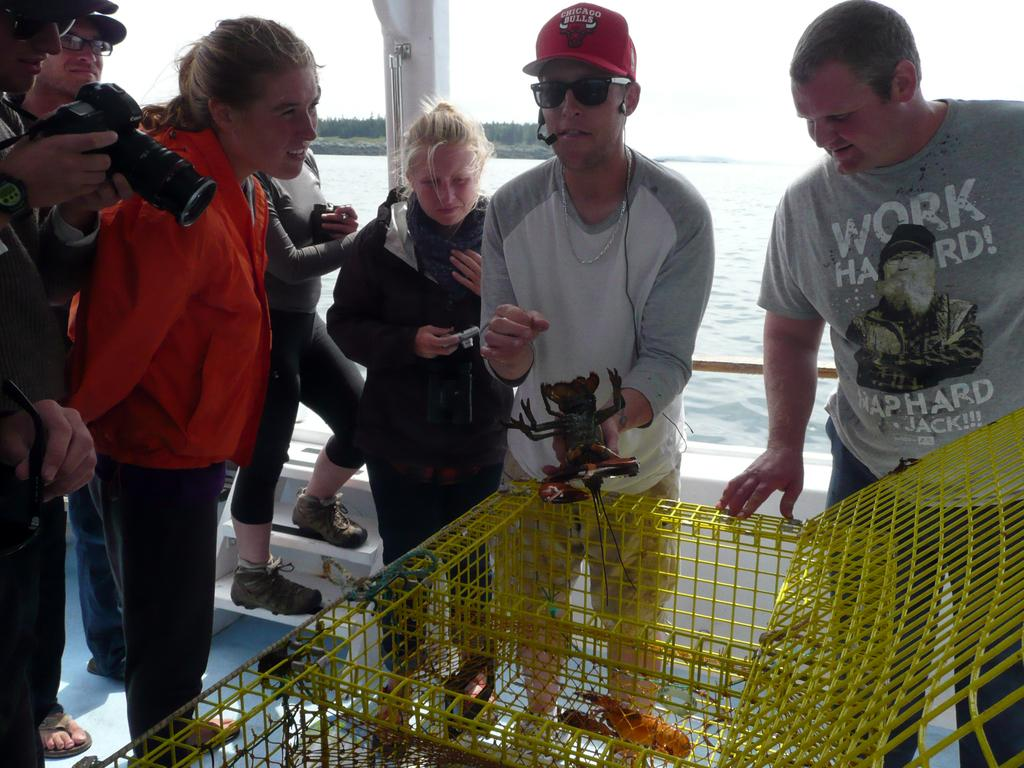What is the general activity of the people in the image? The people in the image are standing. Can you describe the man in the image? The man in the image is holding a camera. What object is present in the image that might contain animals? There is a cage in the image. What can be seen in the distance in the image? Water is visible in the background of the image. What type of lipstick is the man wearing in the image? There is no mention of lipstick or any cosmetic products in the image. The man is holding a camera, and there are people standing nearby. --- Facts: 1. There is a car in the image. 2. The car is red. 3. The car has four wheels. 4. There is a road in the image. 5. The road is paved. Absurd Topics: parrot, dance, mountain Conversation: What is the main subject of the image? The main subject of the image is a car. Can you describe the car's appearance? The car is red and has four wheels. What type of surface is the car driving on in the image? The car is driving on a road in the image. What is the condition of the road? The road is paved. Reasoning: Let's think step by step in order to produce the conversation. We start by identifying the main subject of the image, which is the car. Then, we describe the car's appearance, including its color and the number of wheels. Next, we mention the road, which is the surface the car is driving on. Finally, we describe the condition of the road, which is paved. Absurd Question/Answer: Can you tell me how many parrots are sitting on the car's roof in the image? There are no parrots present in the image. The main subject is a red car with four wheels, driving on a paved road. 